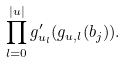Convert formula to latex. <formula><loc_0><loc_0><loc_500><loc_500>\prod _ { l = 0 } ^ { | u | } g ^ { \prime } _ { u _ { l } } ( g _ { u , l } ( b _ { j } ) ) .</formula> 